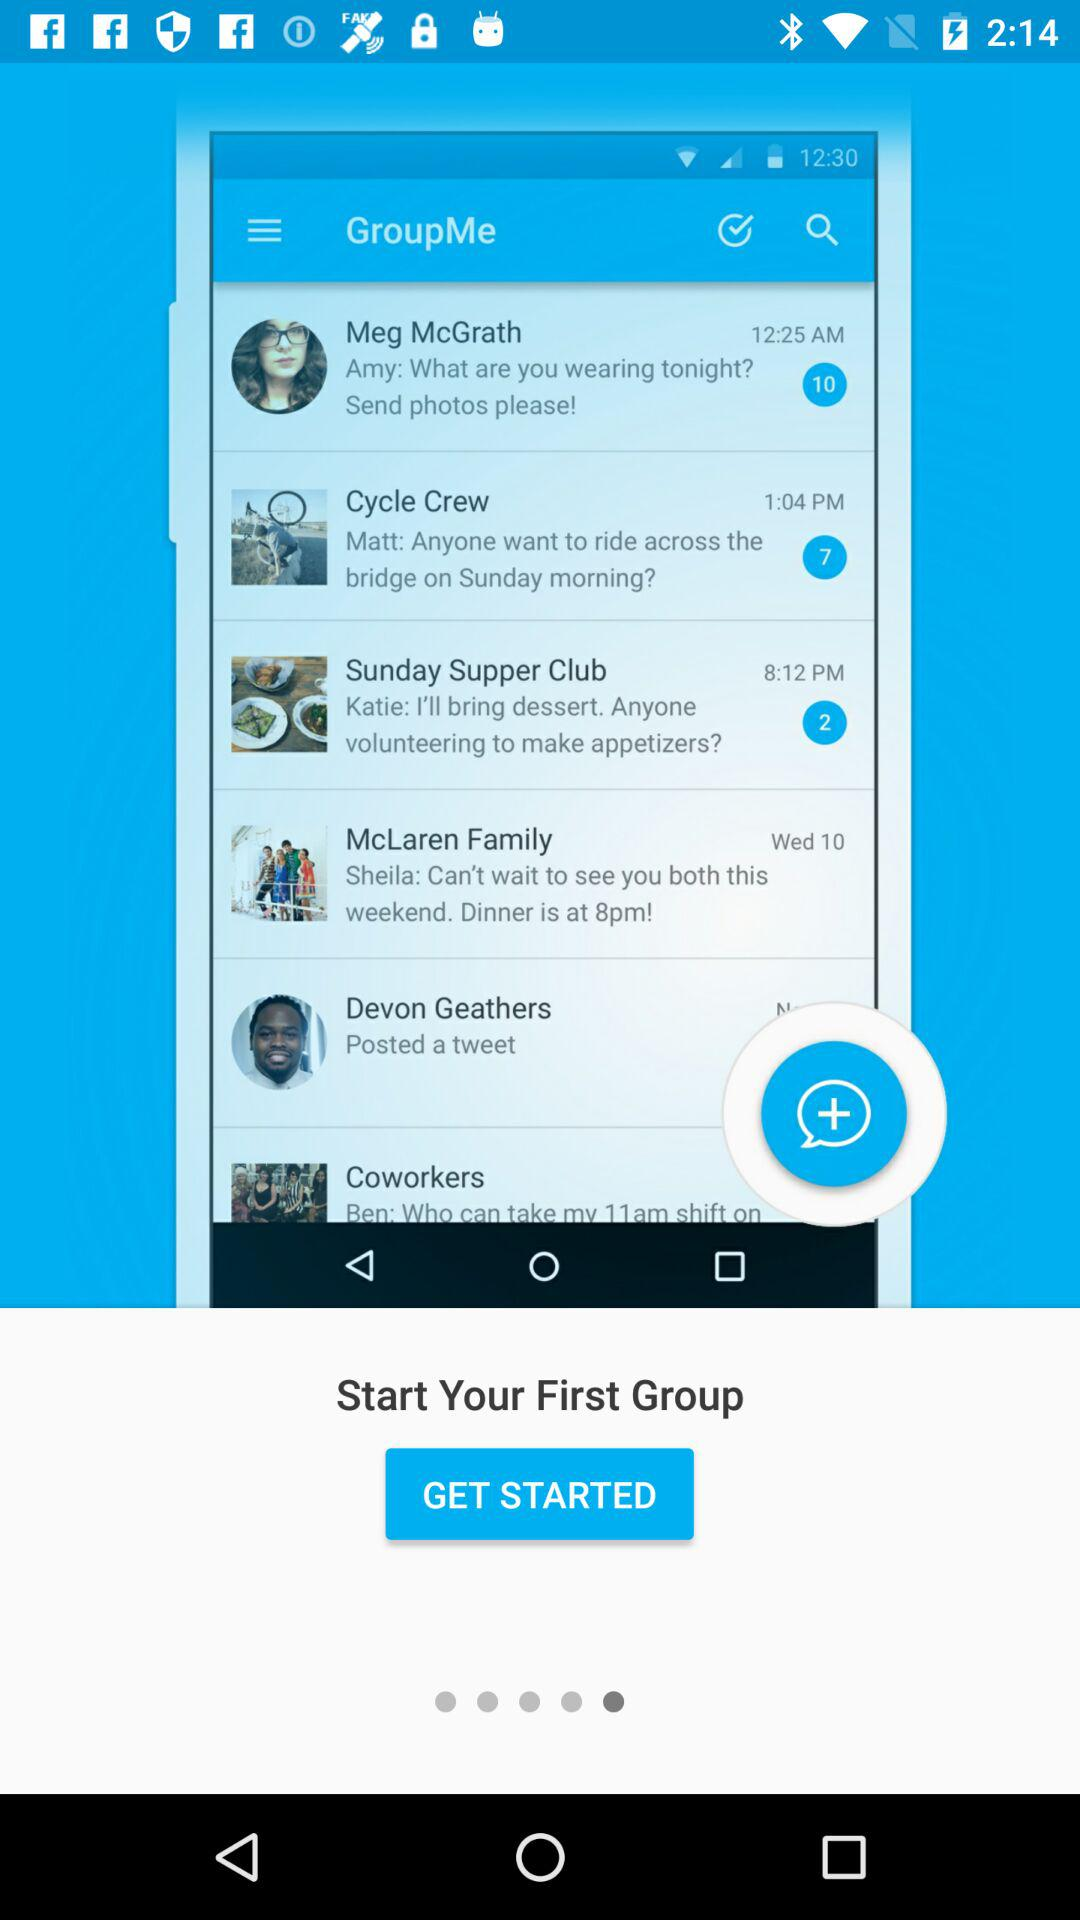How many unread notifications are there in Meg McGrath's chat? The unread notifications in Meg McGrath's chat are 10. 